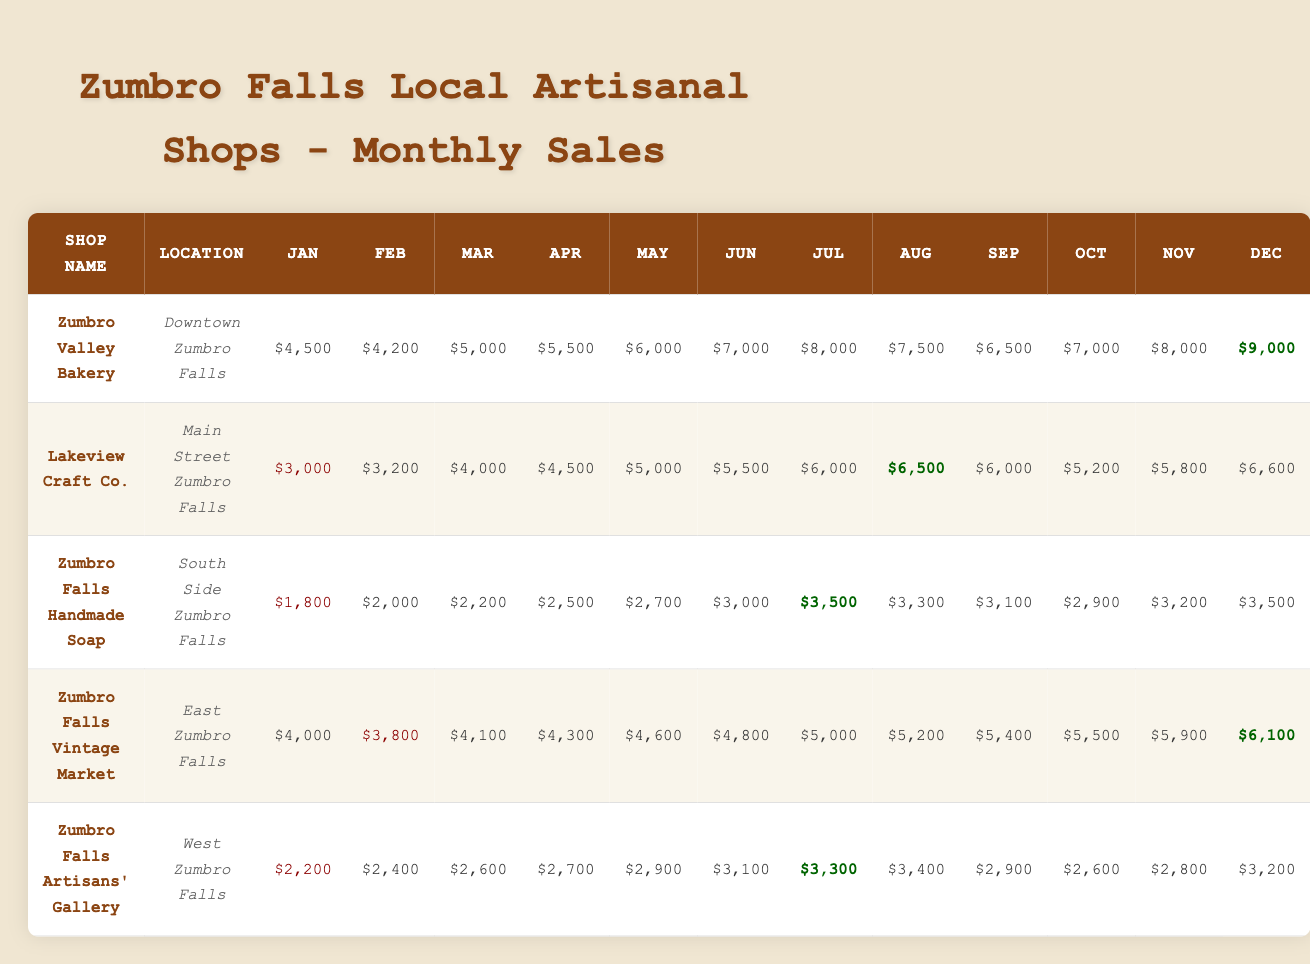What is the highest monthly sales figure recorded for the Zumbro Valley Bakery? The table shows the monthly sales for Zumbro Valley Bakery. The highest figure listed is in December, with sales of $9,000.
Answer: $9,000 Which shop had the lowest sales in January? In January, Zumbro Falls Handmade Soap recorded the lowest sales figure of $1,800 compared to other shops.
Answer: $1,800 Calculate the total sales for Lakeview Craft Co. over the year. To find the total sales for Lakeview Craft Co., we add all monthly sales figures: (3000 + 3200 + 4000 + 4500 + 5000 + 5500 + 6000 + 6500 + 6000 + 5200 + 5800 + 6600) = $60,200.
Answer: $60,200 Did Zumbro Falls Vintage Market experience an increase in sales from October to November? The sales in October were $5,500, and in November, they were $5,900. Since $5,900 is greater than $5,500, there was an increase in sales.
Answer: Yes What is the average monthly sales figure for Zumbro Falls Artisans' Gallery? Calculate the average by adding all monthly sales figures: (2200 + 2400 + 2600 + 2700 + 2900 + 3100 + 3300 + 3400 + 2900 + 2600 + 2800 + 3200) = $34,200. Then divide by 12 months: $34,200 / 12 = $2,850.
Answer: $2,850 Which shop had the largest increase in sales from July to August? For Zumbro Valley Bakery, July sales were $8,000 and August were $7,500 (decrease). Lakeview Craft Co. had $6,000 in July and $6,500 in August (increase). The largest increase is from Lakeview Craft Co. with $500.
Answer: Lakeview Craft Co What was the sales trend for Zumbro Falls Handmade Soap throughout the year? Reviewing the monthly figures, sales started at $1,800 in January and increased slightly each month until July ($3,500), then fluctuated but ended at $3,500 in December. This indicates a general upward trend.
Answer: General upward trend Which shop had the highest sales in June? The sales figures for June show that Zumbro Valley Bakery had the highest sales at $7,000, compared to other shops.
Answer: Zumbro Valley Bakery Was there any month where Zumbro Falls Vintage Market recorded lower sales than Zumbro Falls Handmade Soap? Zumbro Falls Vintage Market's sales were lower than Zumbro Falls Handmade Soap only in January where Vintage was $4,000 and Handmade Soap was $1,800.
Answer: Yes What percentage of Zumbro Valley Bakery's total annual sales does the December figure represent? The annual sales total for Zumbro Valley Bakery is $77,000 ($4,500 + $4,200 + $5,000 + $5,500 + $6,000 + $7,000 + $8,000 + $7,500 + $6,500 + $7,000 + $8,000 + $9,000). The percentage is ($9,000 / $77,000) * 100 = 11.69%.
Answer: 11.69% 